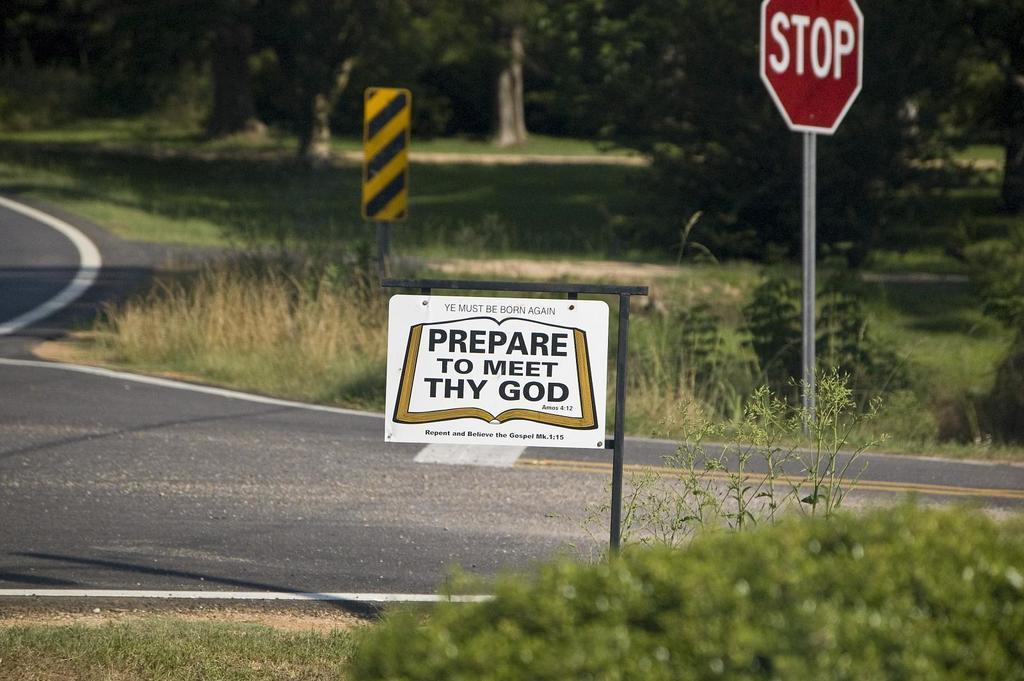Describe this image in one or two sentences. In this image I see the road and I see the grass and few plants and I see 2 boards on which something is written. In the background I see the trees and I see the white and black board over here. 